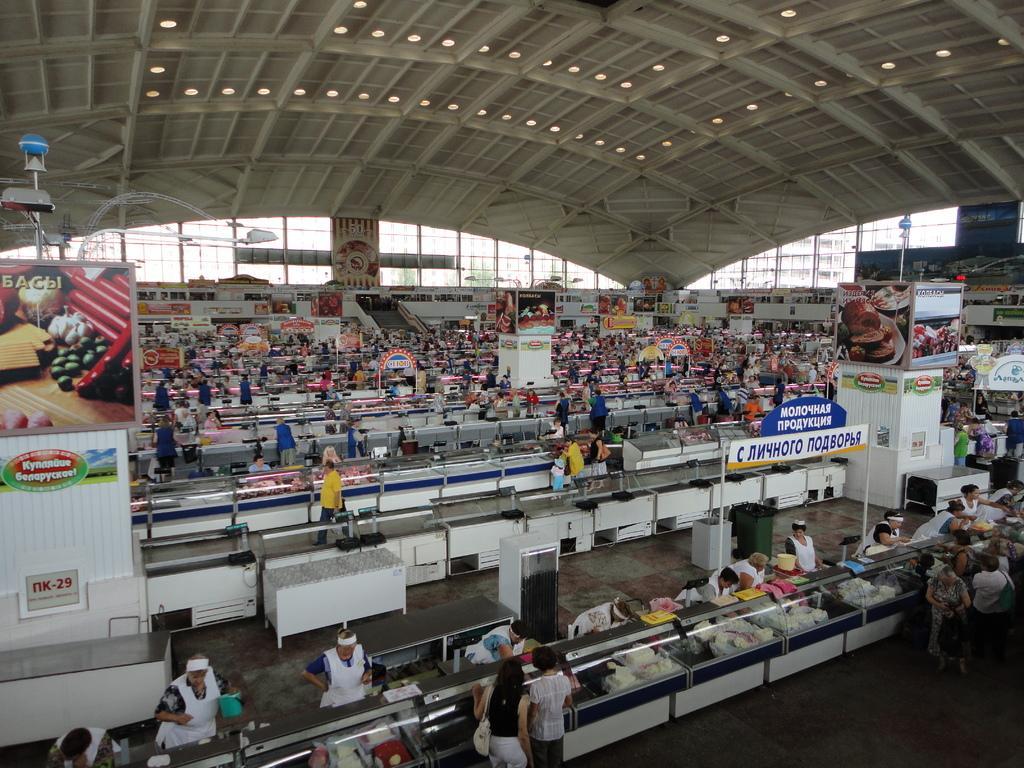Could you give a brief overview of what you see in this image? This image is taken inside a supermarket. There are many people in this image. 